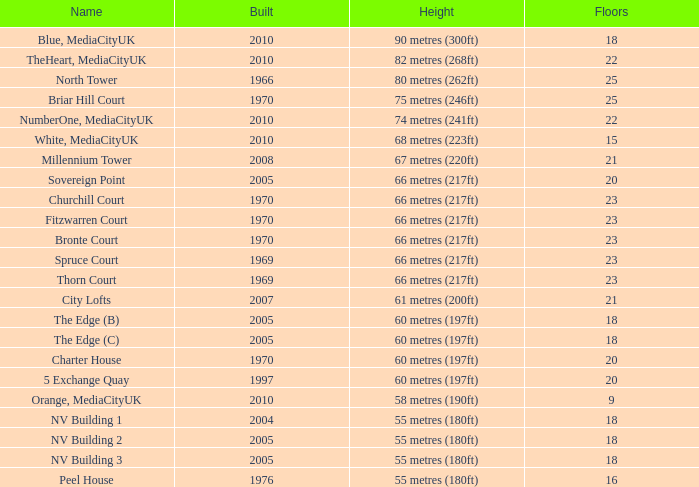What is the verticality, when standing is lesser than 20, when layers is in excess of 9, when creation is 2005, and when appellation is the edge (c)? 60 metres (197ft). 